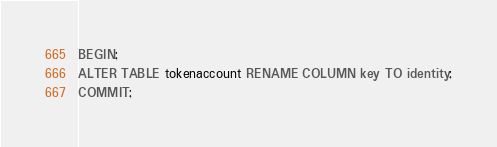<code> <loc_0><loc_0><loc_500><loc_500><_SQL_>BEGIN;
ALTER TABLE tokenaccount RENAME COLUMN key TO identity;
COMMIT;
</code> 